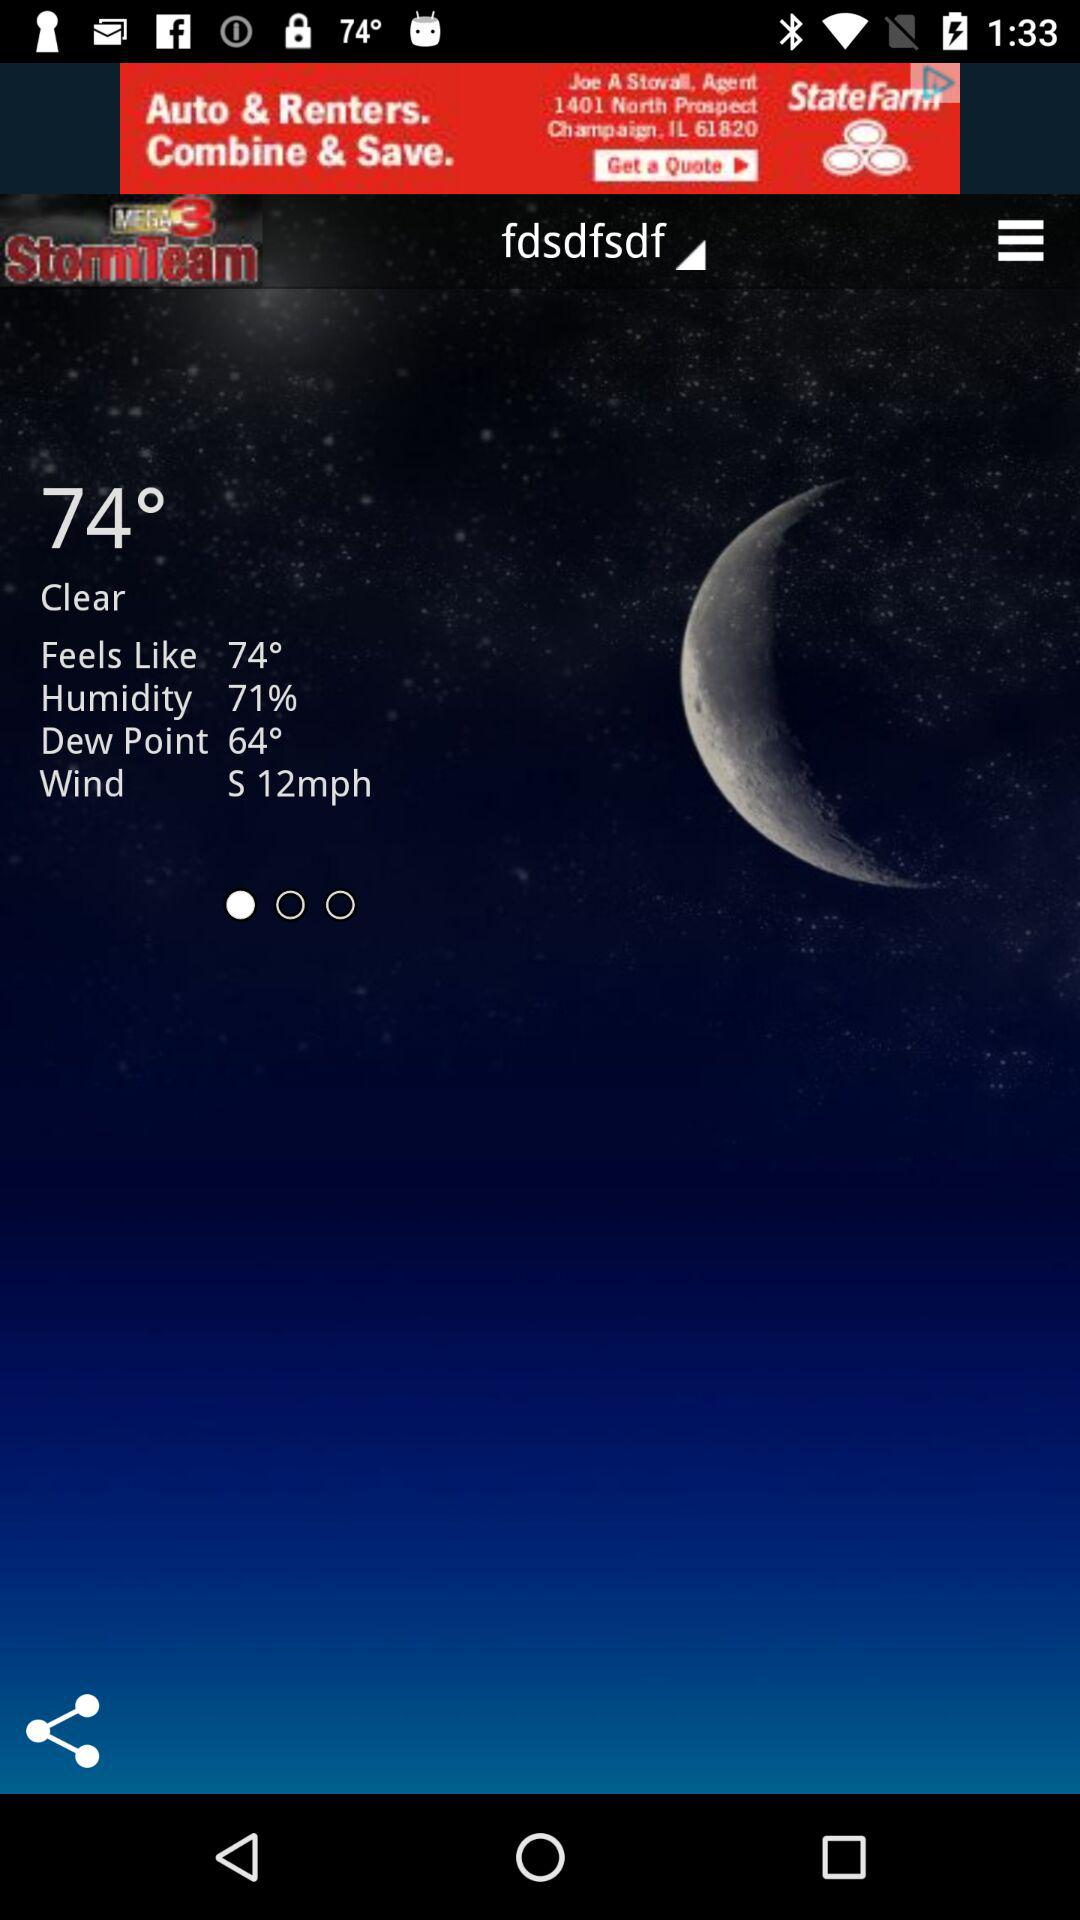How many degrees is the dew point?
Answer the question using a single word or phrase. 64° 